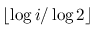<formula> <loc_0><loc_0><loc_500><loc_500>\lfloor \log i / \log 2 \rfloor</formula> 